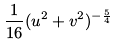<formula> <loc_0><loc_0><loc_500><loc_500>\frac { 1 } { 1 6 } ( u ^ { 2 } + v ^ { 2 } ) ^ { - \frac { 5 } { 4 } }</formula> 